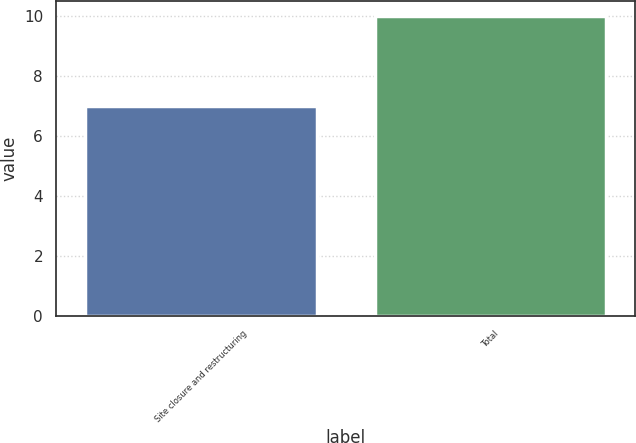Convert chart. <chart><loc_0><loc_0><loc_500><loc_500><bar_chart><fcel>Site closure and restructuring<fcel>Total<nl><fcel>7<fcel>10<nl></chart> 